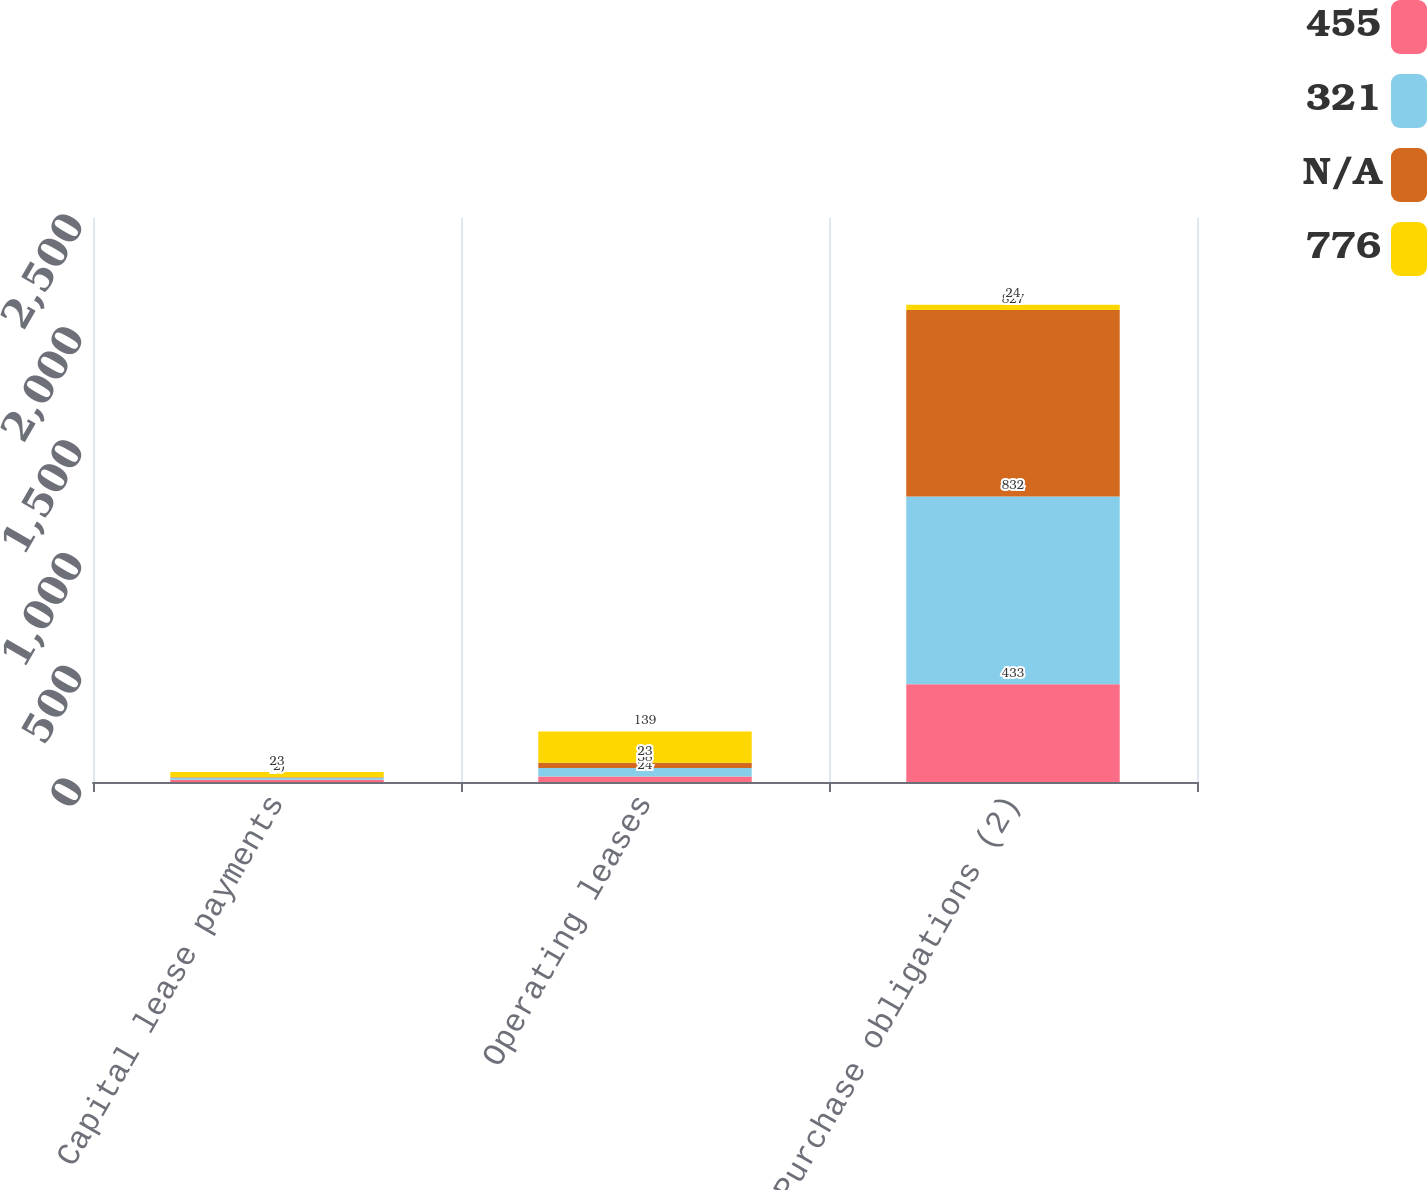<chart> <loc_0><loc_0><loc_500><loc_500><stacked_bar_chart><ecel><fcel>Capital lease payments<fcel>Operating leases<fcel>Purchase obligations (2)<nl><fcel>455<fcel>10<fcel>24<fcel>433<nl><fcel>321<fcel>9<fcel>38<fcel>832<nl><fcel>nan<fcel>2<fcel>23<fcel>827<nl><fcel>776<fcel>23<fcel>139<fcel>24<nl></chart> 